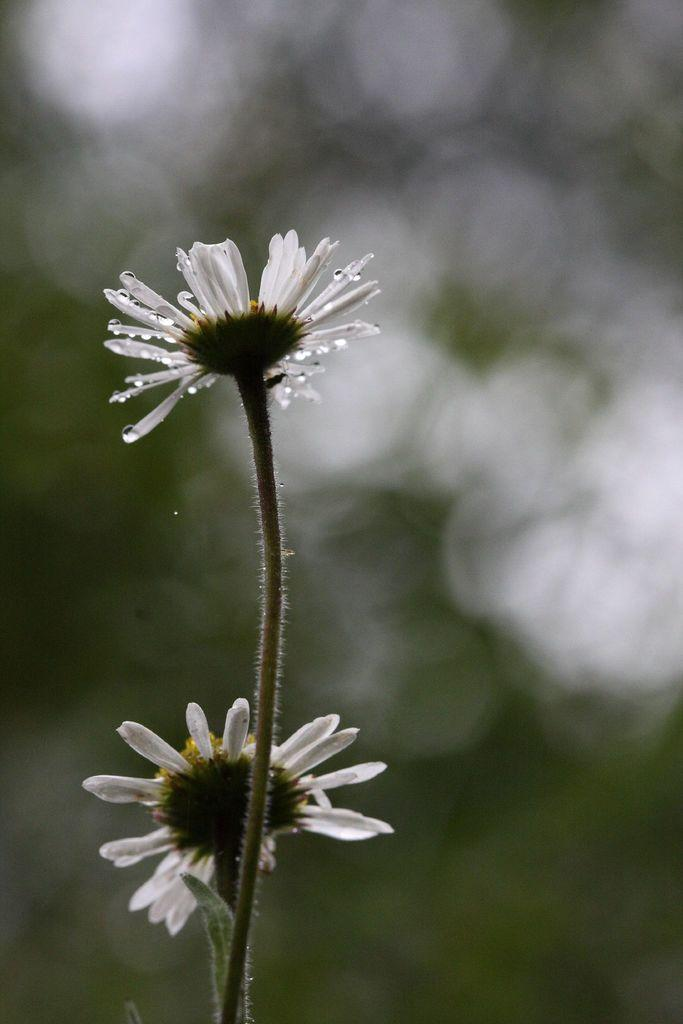What is the main subject of the image? The main subject of the image is a flower. How many white flowers are present in the image? There are two white color flowers in the image. Can you describe the background of the image? The background of the image is blurry. What type of behavior can be observed in the flowers during the morning? There is no behavior to observe in the flowers, as they are not living organisms. Additionally, the time of day is not mentioned in the image. 